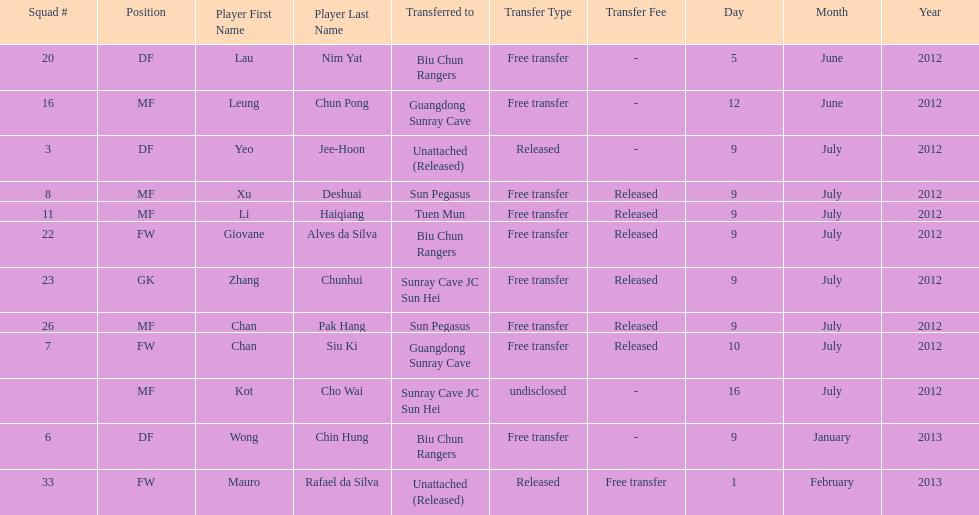Which team did lau nim yat play for after he was transferred? Biu Chun Rangers. 